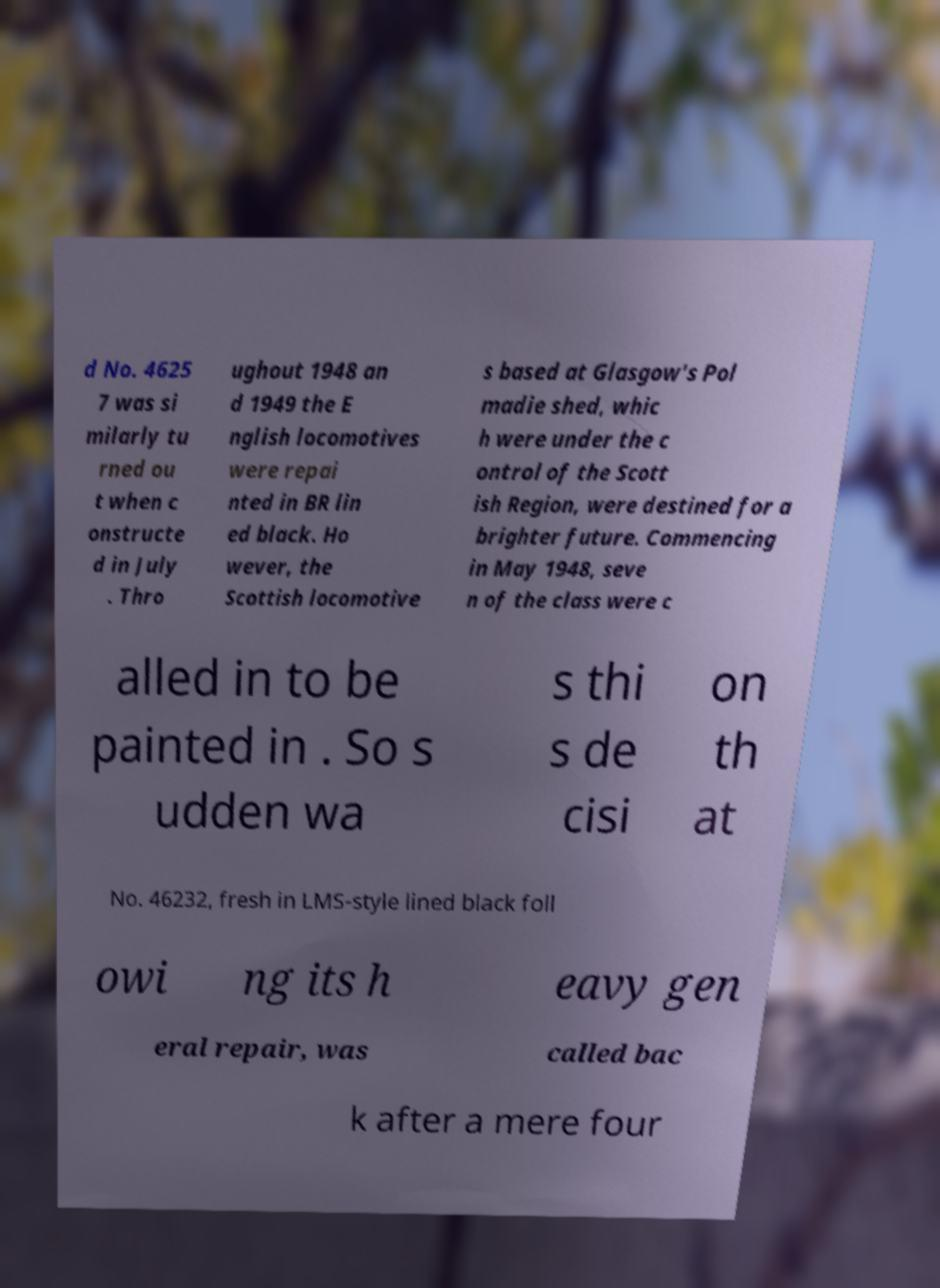I need the written content from this picture converted into text. Can you do that? d No. 4625 7 was si milarly tu rned ou t when c onstructe d in July . Thro ughout 1948 an d 1949 the E nglish locomotives were repai nted in BR lin ed black. Ho wever, the Scottish locomotive s based at Glasgow's Pol madie shed, whic h were under the c ontrol of the Scott ish Region, were destined for a brighter future. Commencing in May 1948, seve n of the class were c alled in to be painted in . So s udden wa s thi s de cisi on th at No. 46232, fresh in LMS-style lined black foll owi ng its h eavy gen eral repair, was called bac k after a mere four 